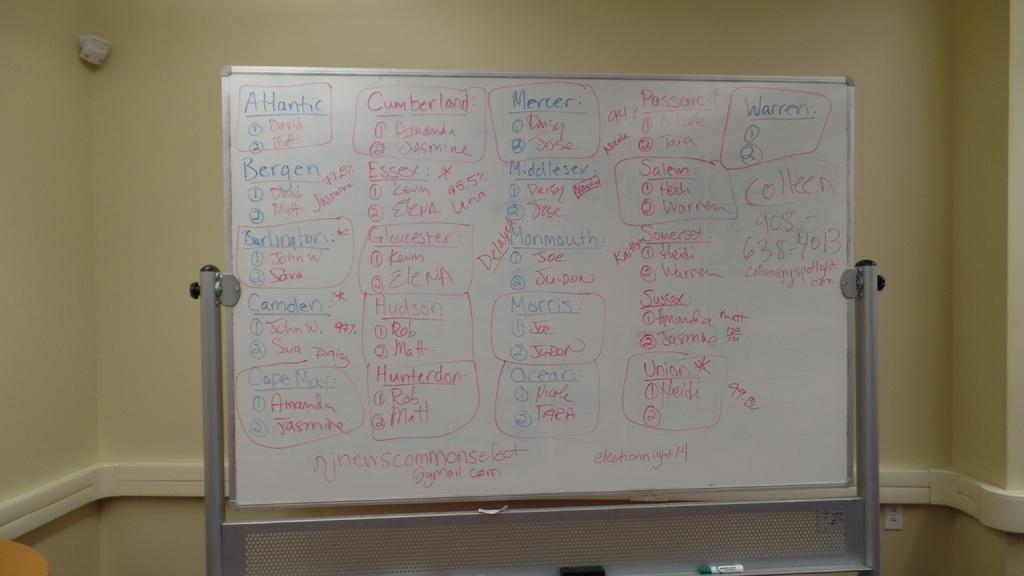<image>
Create a compact narrative representing the image presented. A whiteboard with different colors and words, some say Atlantic, Cumberland and Mercer. 